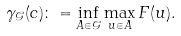Convert formula to latex. <formula><loc_0><loc_0><loc_500><loc_500>\gamma _ { \mathcal { G } } ( c ) \colon = \inf _ { A \in \mathcal { G } } \max _ { u \in A } F ( u ) .</formula> 